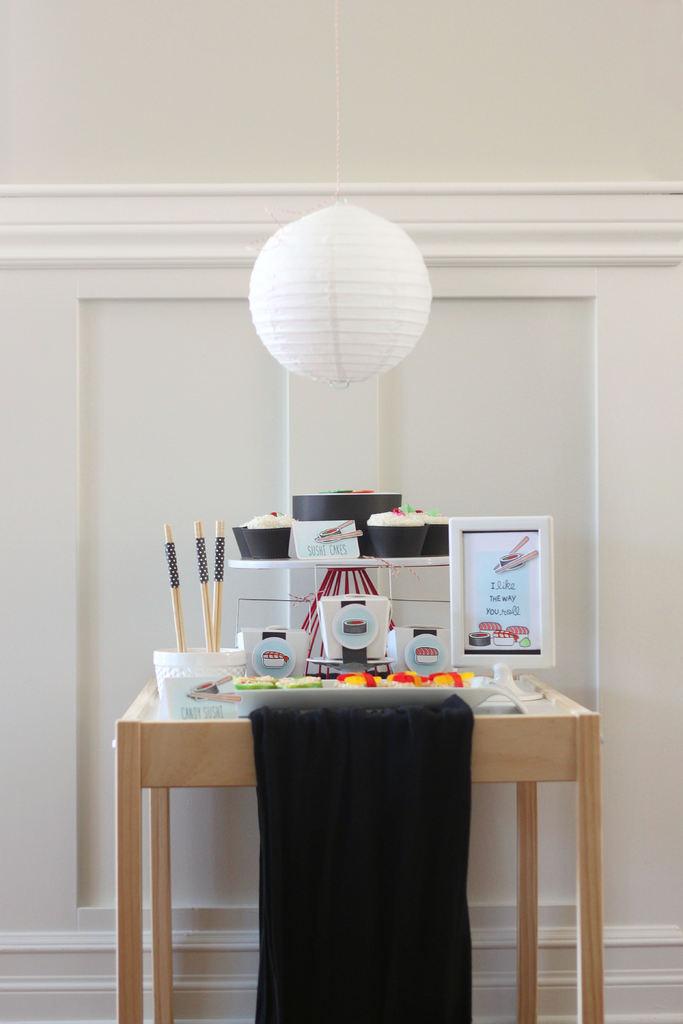Is there an inspirational message in that picture frame on the desk?
Make the answer very short. Yes. 